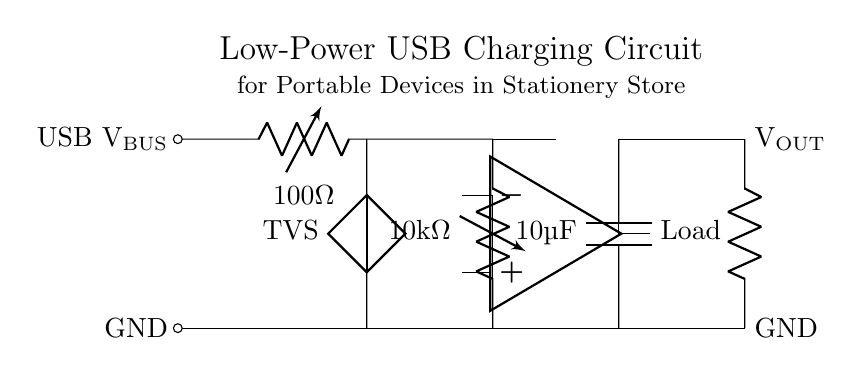What is the resistance value of R1? The resistance value of R1 is shown as 100 ohms in the circuit. This is indicated by the label next to the resistor symbol in the diagram.
Answer: 100 ohm What is the purpose of the TVS component? The TVS (Transient Voltage Suppressor) is used for protecting the circuit from voltage spikes or transients, which could potentially damage the other components. It is directly connected between the positive and ground lines after R1.
Answer: Protection How many microfarads is the output capacitor? The output capacitor is specified to be 10 microfarads as indicated in the label next to the capacitor symbol in the diagram.
Answer: 10 microfarad What is the connection type for the load? The load is connected in a series configuration to the output of the circuit, as indicated by the direct line connecting the load symbol to the output node.
Answer: Series What is the value of R2? The resistance value of R2 is 10,000 ohms, which is indicated by the label next to the resistor symbol in the diagram.
Answer: 10k ohm Why is there an operational amplifier in the circuit? The operational amplifier is used for voltage regulation, ensuring that the output voltage remains stable despite variations in load conditions or input voltage. Its placement in the diagram shows it is integral to maintaining consistent output to the load.
Answer: Voltage regulation 